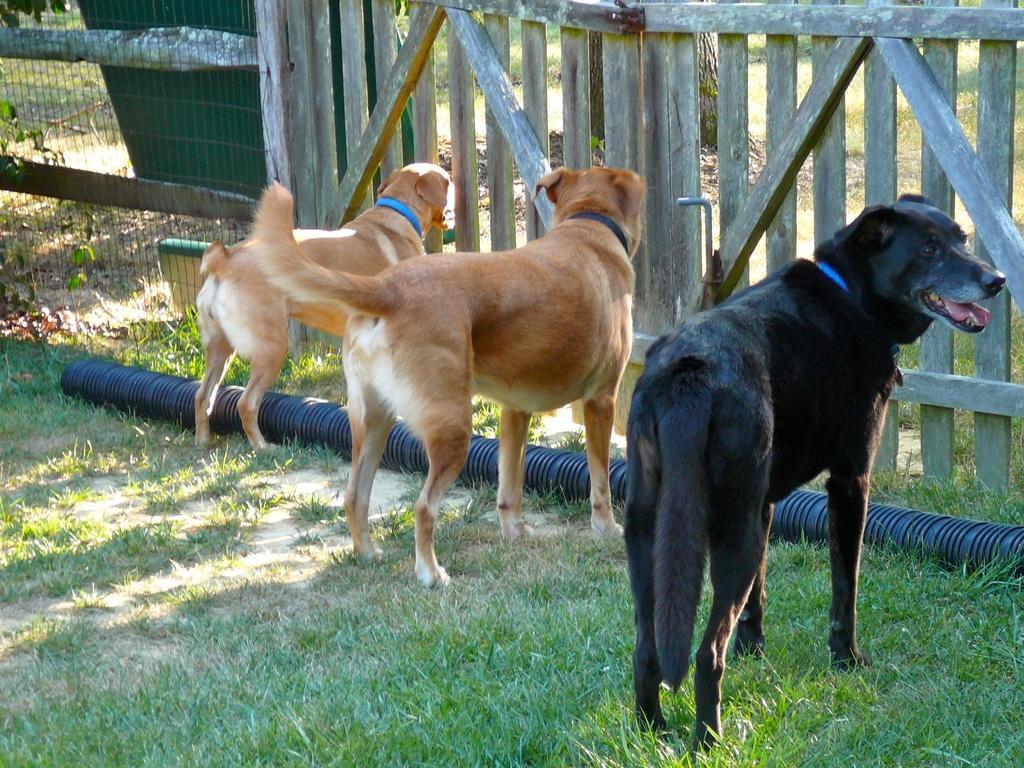Can you describe this image briefly? In this picture we can see few dogs are in a cage and also we can see some grass. 